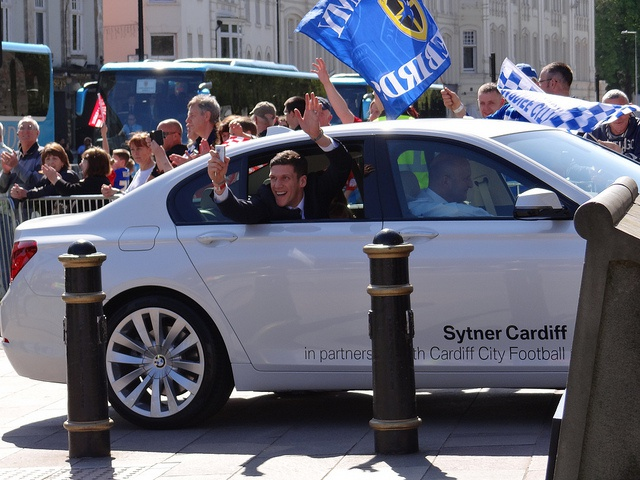Describe the objects in this image and their specific colors. I can see car in black and gray tones, bus in black, navy, white, and gray tones, people in black, brown, navy, and gray tones, people in black, brown, and maroon tones, and bus in black, blue, and gray tones in this image. 